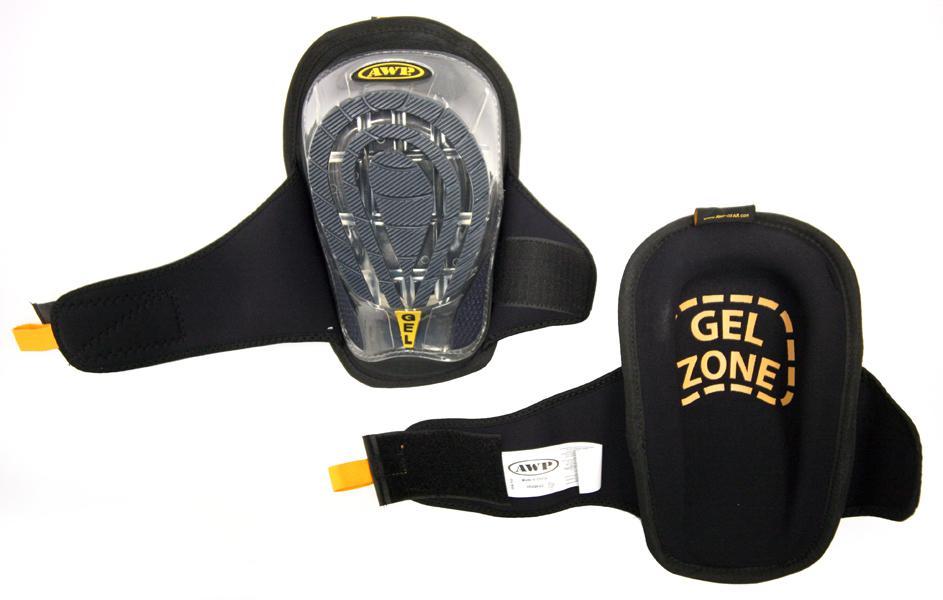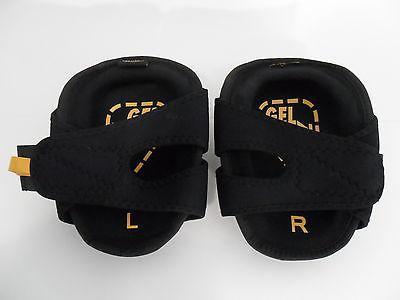The first image is the image on the left, the second image is the image on the right. Given the left and right images, does the statement "In the image on the right, you can clearly see the label that designates which knee this pad goes on." hold true? Answer yes or no. Yes. The first image is the image on the left, the second image is the image on the right. Considering the images on both sides, is "At least one knee pad tells you which knee to put it on." valid? Answer yes or no. Yes. 